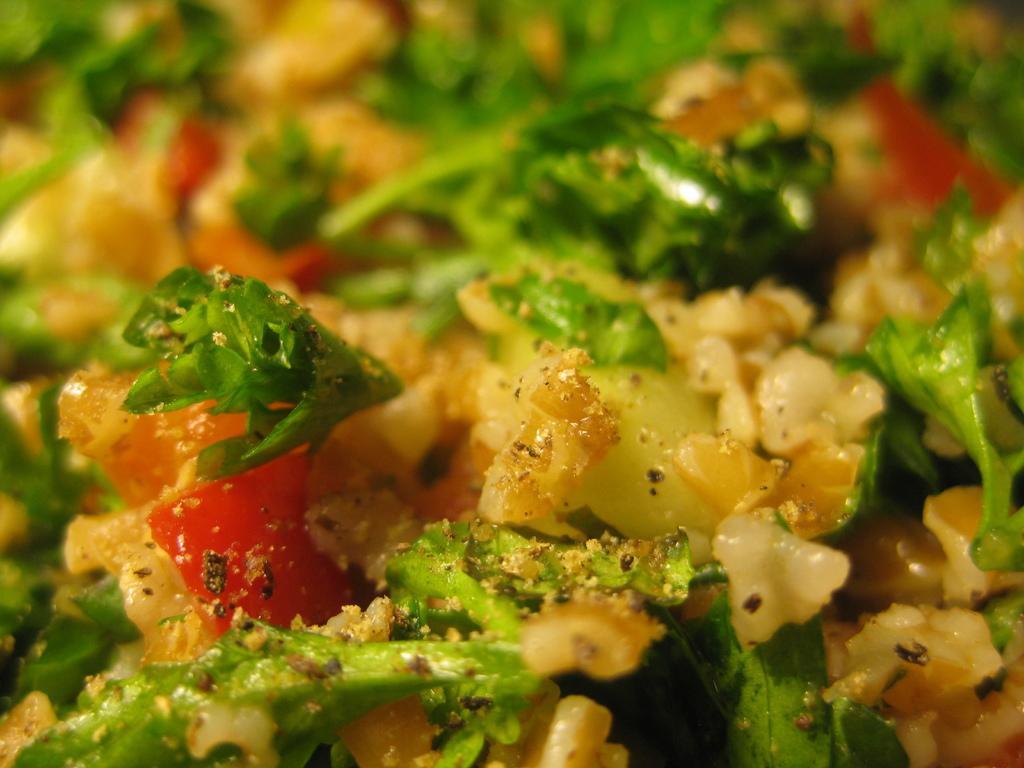Please provide a concise description of this image. In this image we can see there is a food item. 